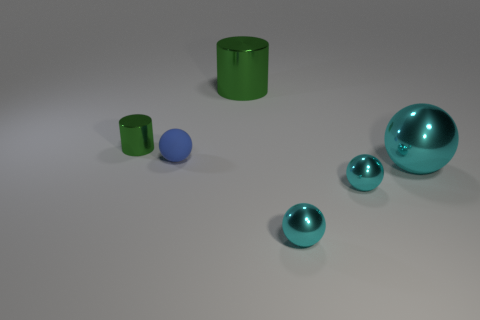How many things are blue matte spheres or metallic cylinders in front of the big green cylinder?
Your answer should be very brief. 2. Do the big green cylinder that is behind the tiny green metal thing and the small green cylinder have the same material?
Your response must be concise. Yes. Is there anything else that has the same size as the blue object?
Your answer should be compact. Yes. There is a cylinder right of the tiny thing that is left of the matte object; what is its material?
Give a very brief answer. Metal. Are there more tiny blue rubber spheres on the right side of the big green shiny cylinder than big metallic cylinders that are to the left of the tiny rubber object?
Your response must be concise. No. What is the size of the matte ball?
Your answer should be very brief. Small. Is the color of the cylinder right of the blue rubber thing the same as the tiny metal cylinder?
Provide a short and direct response. Yes. Are there any other things that have the same shape as the blue object?
Keep it short and to the point. Yes. Are there any tiny metallic balls in front of the cylinder that is to the left of the small blue object?
Make the answer very short. Yes. Is the number of spheres that are in front of the large cyan sphere less than the number of tiny green metallic cylinders in front of the small green metallic thing?
Your response must be concise. No. 